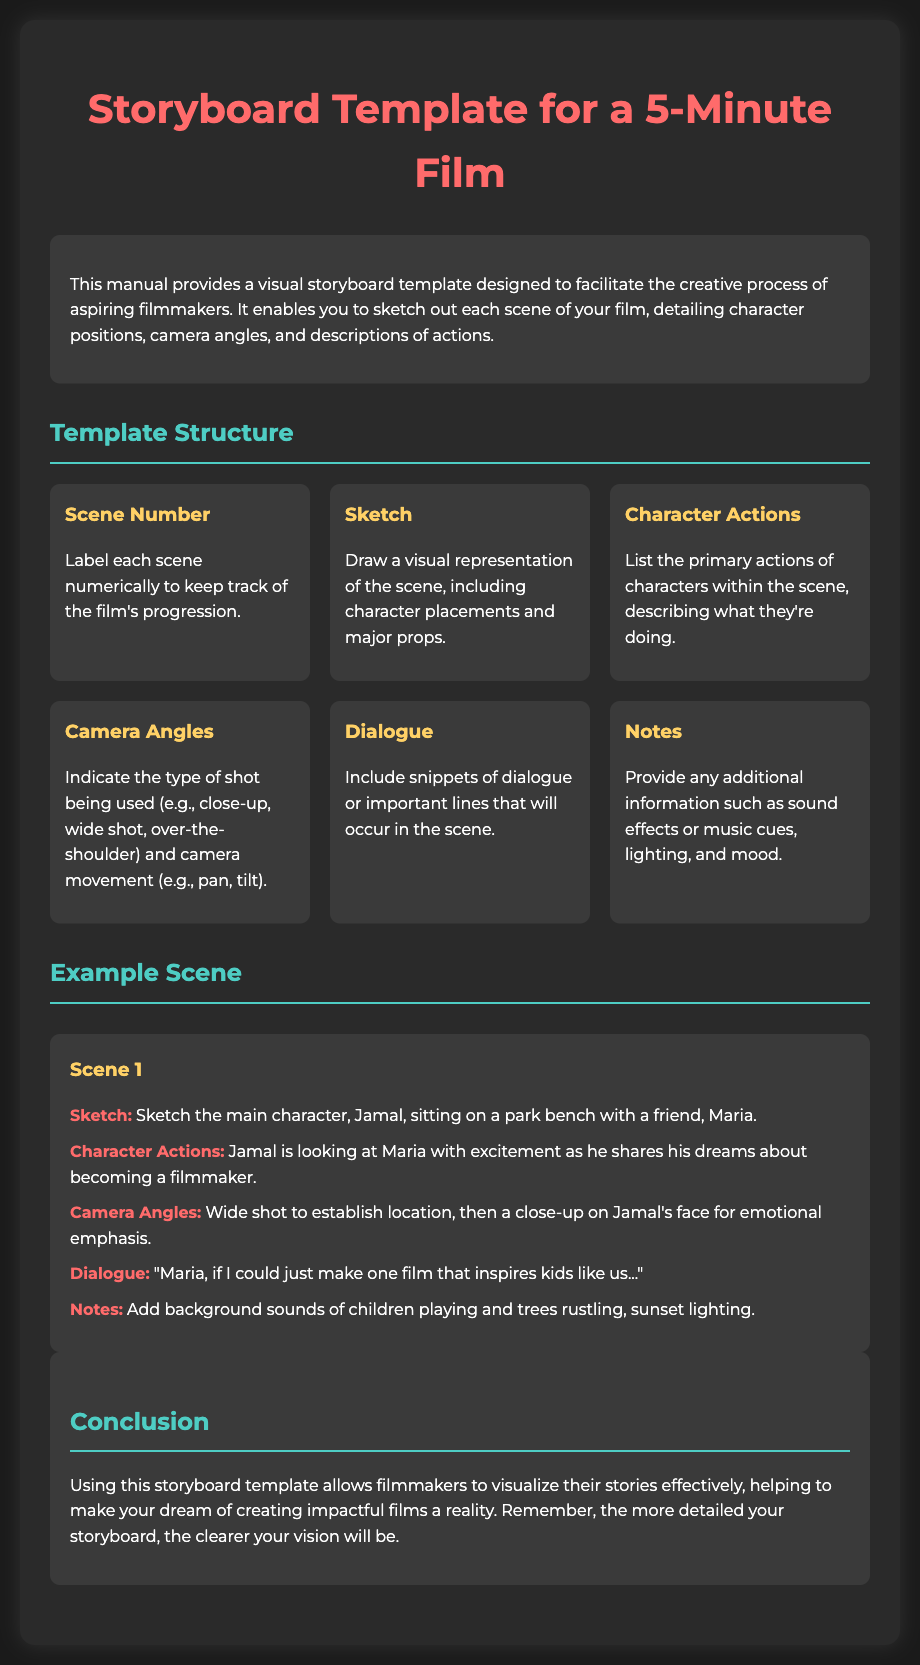what is the title of the manual? The title of the manual is found within the heading of the document.
Answer: Storyboard Template for a 5-Minute Film how many columns are in the template structure? The document specifies that the template structure is composed of a grid with multiple columns listed within it.
Answer: Six what is the primary focus of the manual? The introduction provides information on the purpose of the manual, which is to help filmmakers visualize their film ideas.
Answer: Facilitate creative process who is the main character in the example scene? The example scene describes the character featured prominently in the sketch and actions.
Answer: Jamal what type of shot is suggested for emotional emphasis? The example scene indicates the type of shot to be used for highlighting character emotions.
Answer: Close-up what essential information is included in the notes section? The notes section mentions additional details that can enhance the scene, specifying what to consider.
Answer: Background sounds how does this template help filmmakers? The conclusion explains the benefits of using the storyboard template for filmmakers in visualizing their stories.
Answer: Visualize stories effectively 